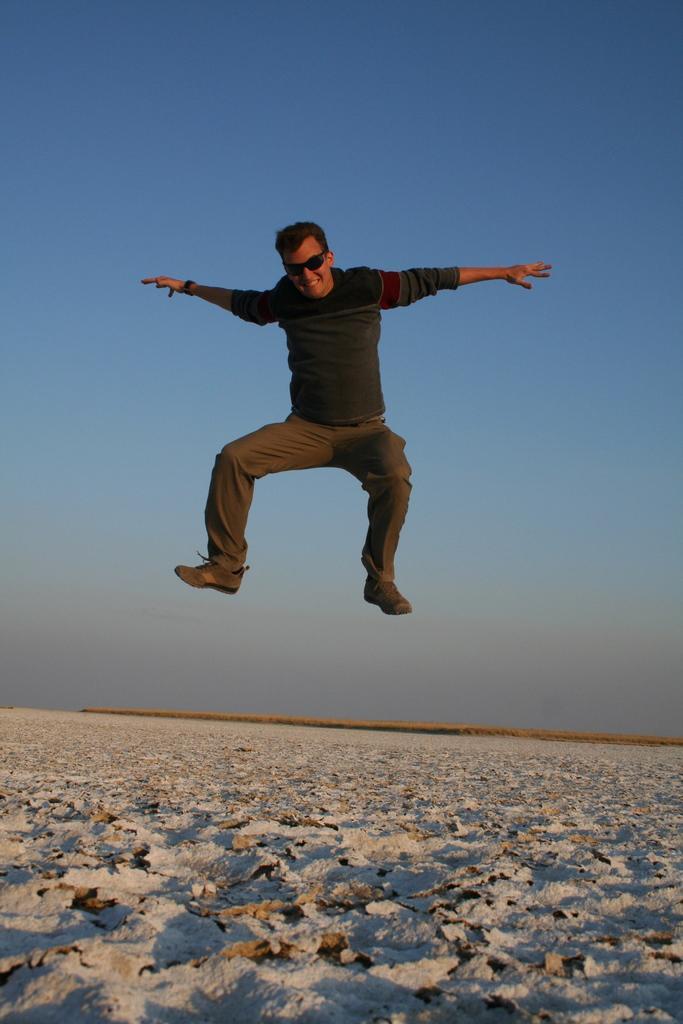Could you give a brief overview of what you see in this image? In this image I can see the person in the air. The person is wearing the black, grey and brown color dress and also goggles. In the bottom I can see the sand. I can see the blue sky in the back. 